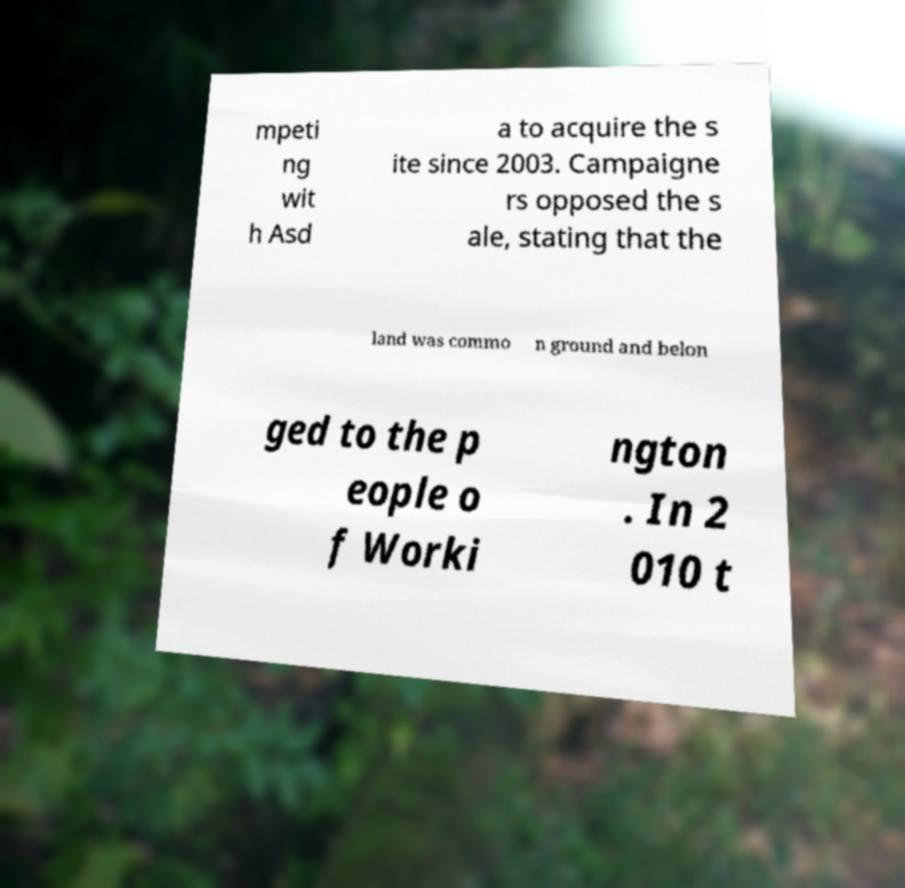For documentation purposes, I need the text within this image transcribed. Could you provide that? mpeti ng wit h Asd a to acquire the s ite since 2003. Campaigne rs opposed the s ale, stating that the land was commo n ground and belon ged to the p eople o f Worki ngton . In 2 010 t 